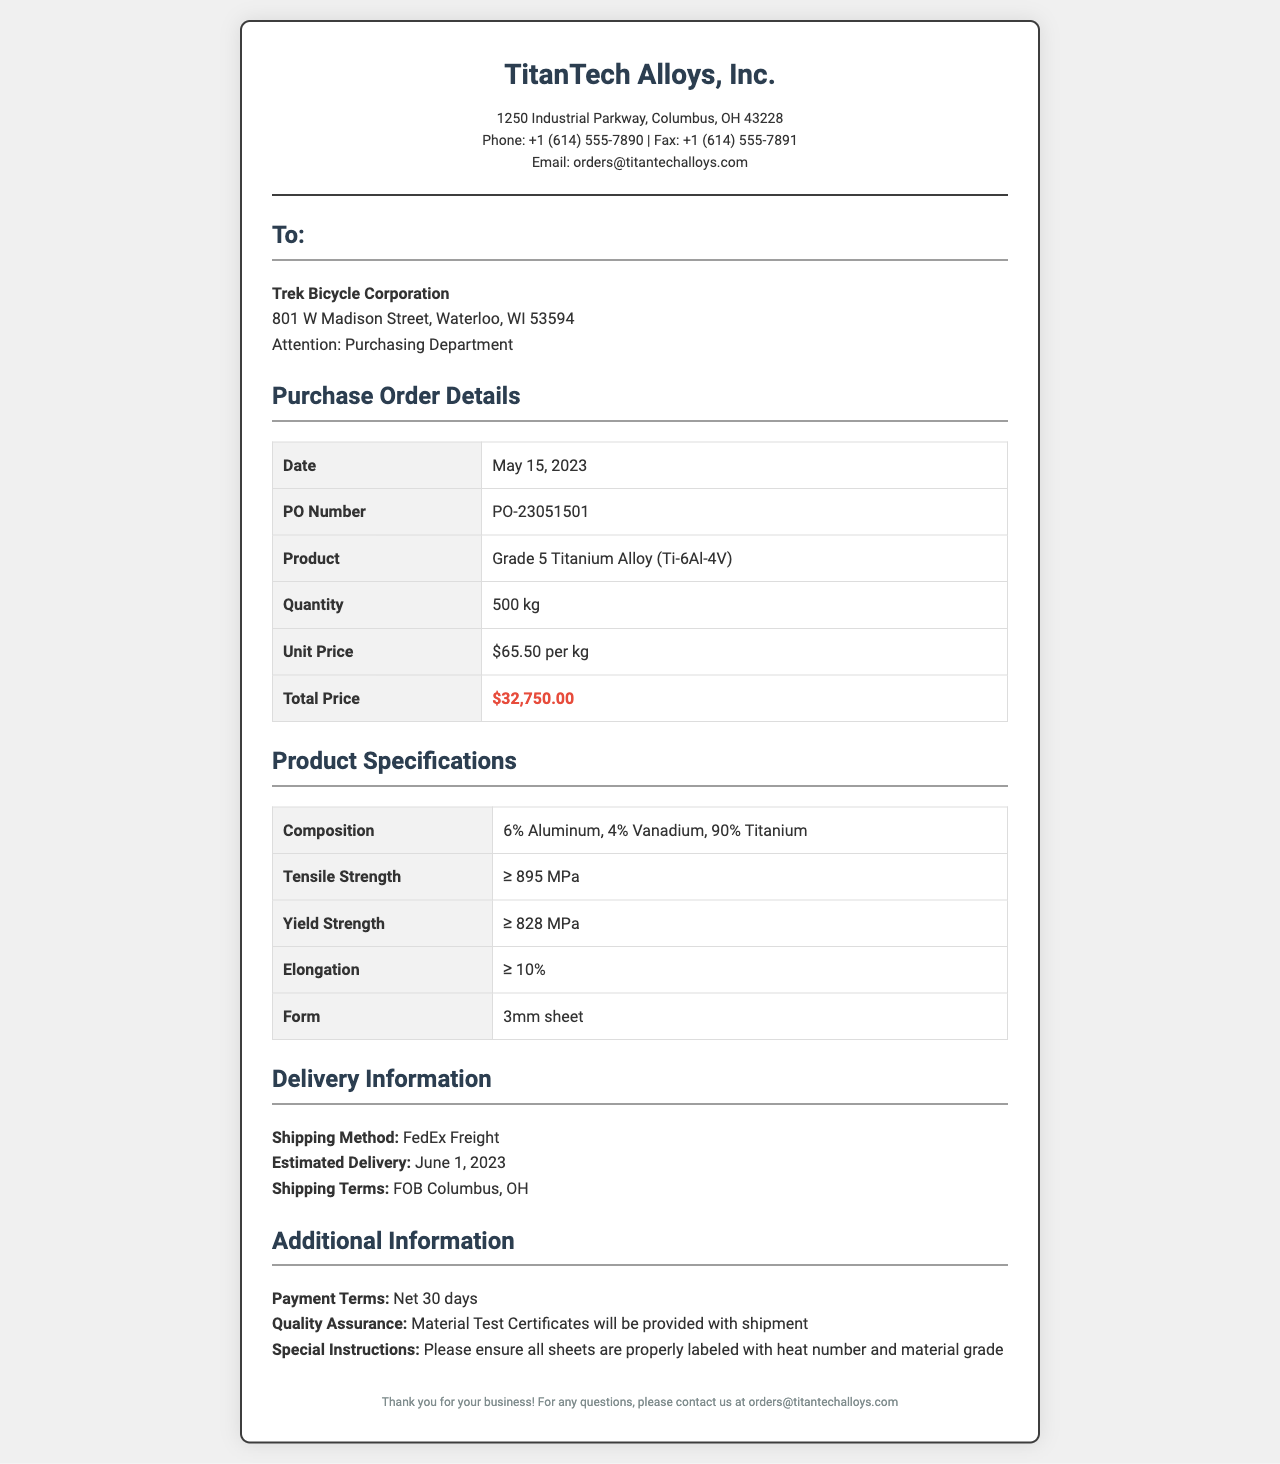What is the PO Number? The PO Number is indicated in the order details section of the document, which is PO-23051501.
Answer: PO-23051501 What is the delivery method? The delivery method is stated in the delivery information section, where it mentions FedEx Freight.
Answer: FedEx Freight What is the quantity ordered? The quantity ordered is listed in the purchase order details, which is 500 kg.
Answer: 500 kg When is the estimated delivery date? The estimated delivery date is found in the delivery information section, stated as June 1, 2023.
Answer: June 1, 2023 What are the payment terms? The payment terms are outlined in the additional information section, noted as Net 30 days.
Answer: Net 30 days What is the total price for the order? The total price is highlighted in the order details section, which is $32,750.00.
Answer: $32,750.00 What is the composition of the titanium alloy? The composition of the titanium alloy is detailed in the product specifications, which is 6% Aluminum, 4% Vanadium, 90% Titanium.
Answer: 6% Aluminum, 4% Vanadium, 90% Titanium What is the contact email for orders? The contact email for orders is found at the top in the contact information, specified as orders@titantechalloys.com.
Answer: orders@titantechalloys.com What special instructions are mentioned? The special instructions are outlined in the additional information section and state to ensure all sheets are properly labeled with heat number and material grade.
Answer: Please ensure all sheets are properly labeled with heat number and material grade 